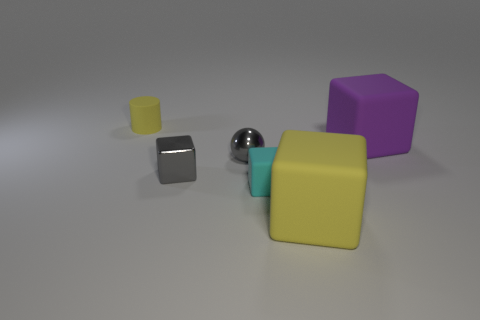There is a yellow matte object that is the same shape as the small cyan matte thing; what size is it? The yellow matte object in the image, which shares the same cube shape as the small cyan one, is large in comparison to it. 